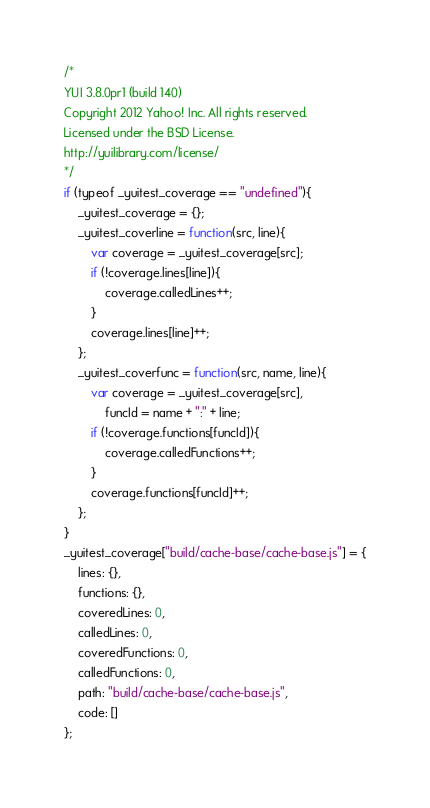<code> <loc_0><loc_0><loc_500><loc_500><_JavaScript_>/*
YUI 3.8.0pr1 (build 140)
Copyright 2012 Yahoo! Inc. All rights reserved.
Licensed under the BSD License.
http://yuilibrary.com/license/
*/
if (typeof _yuitest_coverage == "undefined"){
    _yuitest_coverage = {};
    _yuitest_coverline = function(src, line){
        var coverage = _yuitest_coverage[src];
        if (!coverage.lines[line]){
            coverage.calledLines++;
        }
        coverage.lines[line]++;
    };
    _yuitest_coverfunc = function(src, name, line){
        var coverage = _yuitest_coverage[src],
            funcId = name + ":" + line;
        if (!coverage.functions[funcId]){
            coverage.calledFunctions++;
        }
        coverage.functions[funcId]++;
    };
}
_yuitest_coverage["build/cache-base/cache-base.js"] = {
    lines: {},
    functions: {},
    coveredLines: 0,
    calledLines: 0,
    coveredFunctions: 0,
    calledFunctions: 0,
    path: "build/cache-base/cache-base.js",
    code: []
};</code> 